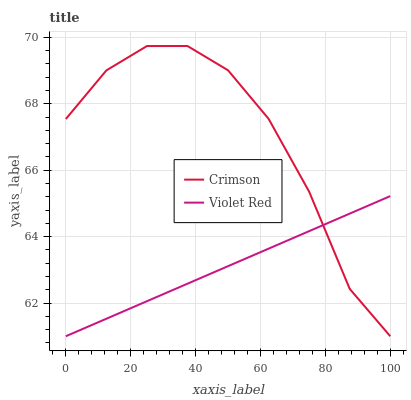Does Violet Red have the minimum area under the curve?
Answer yes or no. Yes. Does Crimson have the maximum area under the curve?
Answer yes or no. Yes. Does Violet Red have the maximum area under the curve?
Answer yes or no. No. Is Violet Red the smoothest?
Answer yes or no. Yes. Is Crimson the roughest?
Answer yes or no. Yes. Is Violet Red the roughest?
Answer yes or no. No. Does Crimson have the lowest value?
Answer yes or no. Yes. Does Crimson have the highest value?
Answer yes or no. Yes. Does Violet Red have the highest value?
Answer yes or no. No. Does Violet Red intersect Crimson?
Answer yes or no. Yes. Is Violet Red less than Crimson?
Answer yes or no. No. Is Violet Red greater than Crimson?
Answer yes or no. No. 